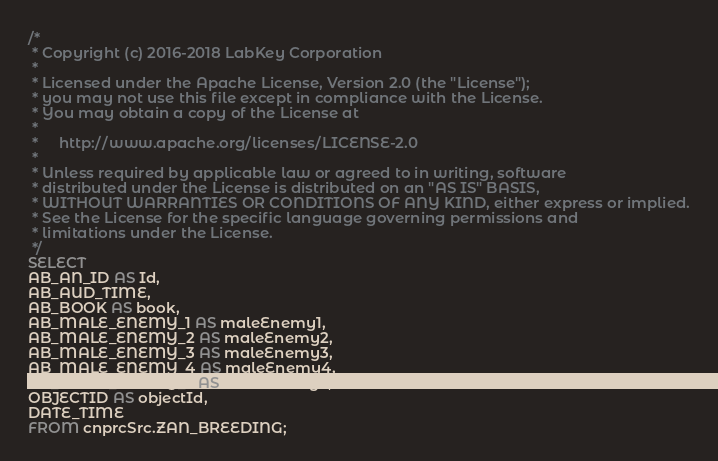Convert code to text. <code><loc_0><loc_0><loc_500><loc_500><_SQL_>/*
 * Copyright (c) 2016-2018 LabKey Corporation
 *
 * Licensed under the Apache License, Version 2.0 (the "License");
 * you may not use this file except in compliance with the License.
 * You may obtain a copy of the License at
 *
 *     http://www.apache.org/licenses/LICENSE-2.0
 *
 * Unless required by applicable law or agreed to in writing, software
 * distributed under the License is distributed on an "AS IS" BASIS,
 * WITHOUT WARRANTIES OR CONDITIONS OF ANY KIND, either express or implied.
 * See the License for the specific language governing permissions and
 * limitations under the License.
 */
SELECT
AB_AN_ID AS Id,
AB_AUD_TIME,
AB_BOOK AS book,
AB_MALE_ENEMY_1 AS maleEnemy1,
AB_MALE_ENEMY_2 AS maleEnemy2,
AB_MALE_ENEMY_3 AS maleEnemy3,
AB_MALE_ENEMY_4 AS maleEnemy4,
AB_MALE_ENEMY_5 AS maleEnemy5,
OBJECTID AS objectId,
DATE_TIME
FROM cnprcSrc.ZAN_BREEDING;</code> 